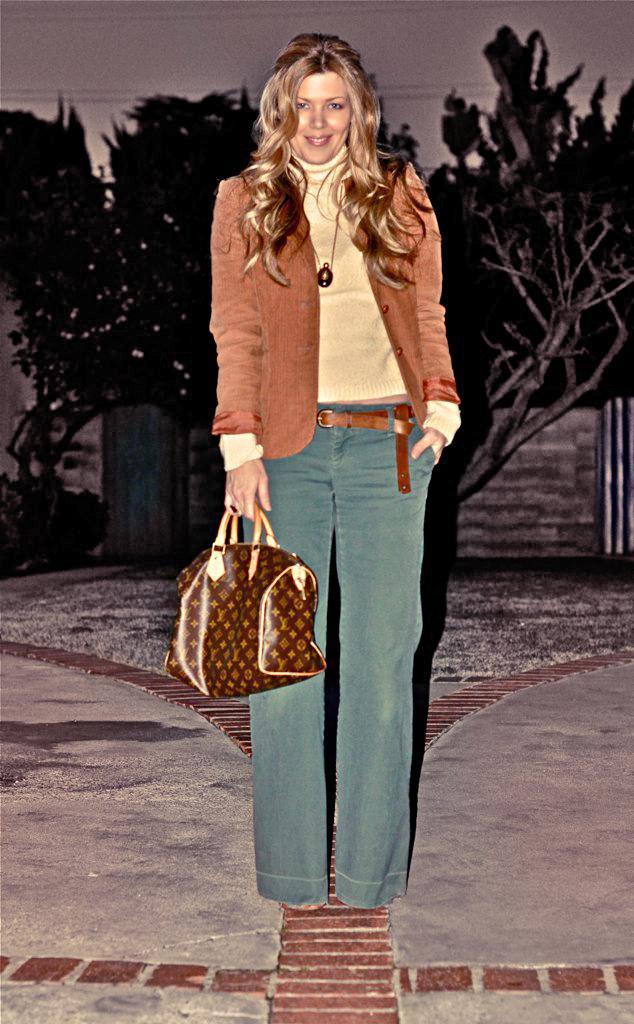Could you give a brief overview of what you see in this image? This image is clicked in a corridor. There is woman standing and wearing a brown jacket and holding a bag in her hand. In the background, there are trees , wall and sky. 